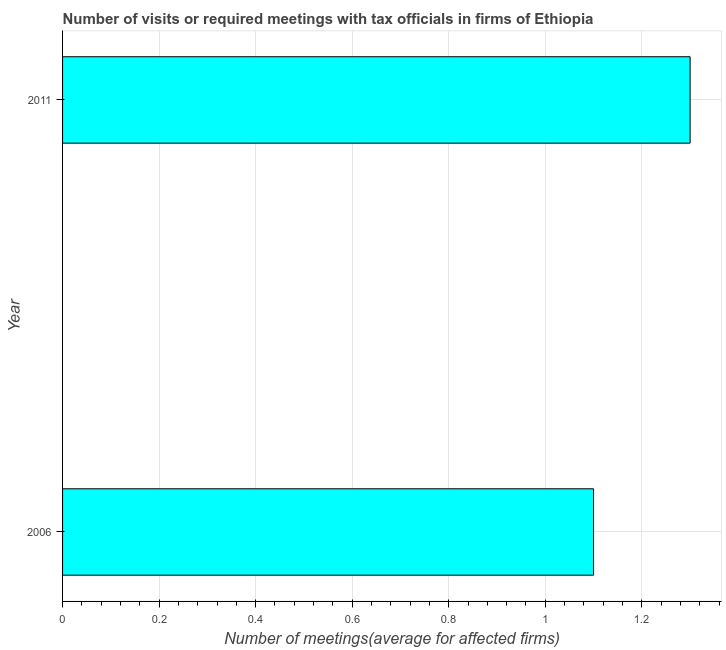Does the graph contain any zero values?
Ensure brevity in your answer.  No. What is the title of the graph?
Give a very brief answer. Number of visits or required meetings with tax officials in firms of Ethiopia. What is the label or title of the X-axis?
Provide a succinct answer. Number of meetings(average for affected firms). What is the label or title of the Y-axis?
Make the answer very short. Year. What is the number of required meetings with tax officials in 2011?
Your answer should be very brief. 1.3. In which year was the number of required meetings with tax officials maximum?
Your response must be concise. 2011. In which year was the number of required meetings with tax officials minimum?
Provide a short and direct response. 2006. What is the sum of the number of required meetings with tax officials?
Provide a short and direct response. 2.4. What is the median number of required meetings with tax officials?
Offer a terse response. 1.2. In how many years, is the number of required meetings with tax officials greater than 0.08 ?
Ensure brevity in your answer.  2. What is the ratio of the number of required meetings with tax officials in 2006 to that in 2011?
Keep it short and to the point. 0.85. Is the number of required meetings with tax officials in 2006 less than that in 2011?
Offer a terse response. Yes. Are all the bars in the graph horizontal?
Offer a very short reply. Yes. Are the values on the major ticks of X-axis written in scientific E-notation?
Keep it short and to the point. No. What is the Number of meetings(average for affected firms) of 2011?
Your answer should be very brief. 1.3. What is the ratio of the Number of meetings(average for affected firms) in 2006 to that in 2011?
Give a very brief answer. 0.85. 